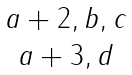<formula> <loc_0><loc_0><loc_500><loc_500>\begin{matrix} { a + 2 , b , c } \\ { a + 3 , d } \end{matrix}</formula> 